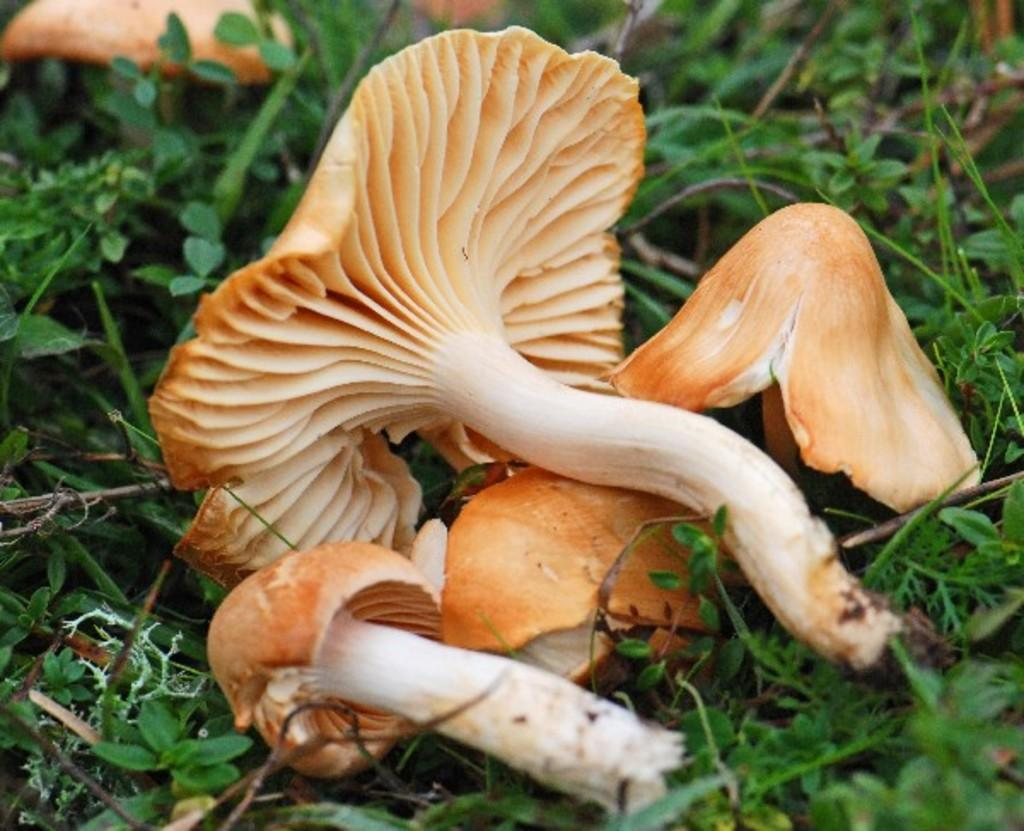What type of fungi can be seen in the image? There are mushrooms in the image. What other living organisms are present in the image? There are plants in the image. What statement does the horse make in the image? There is no horse present in the image, so it cannot make any statements. 